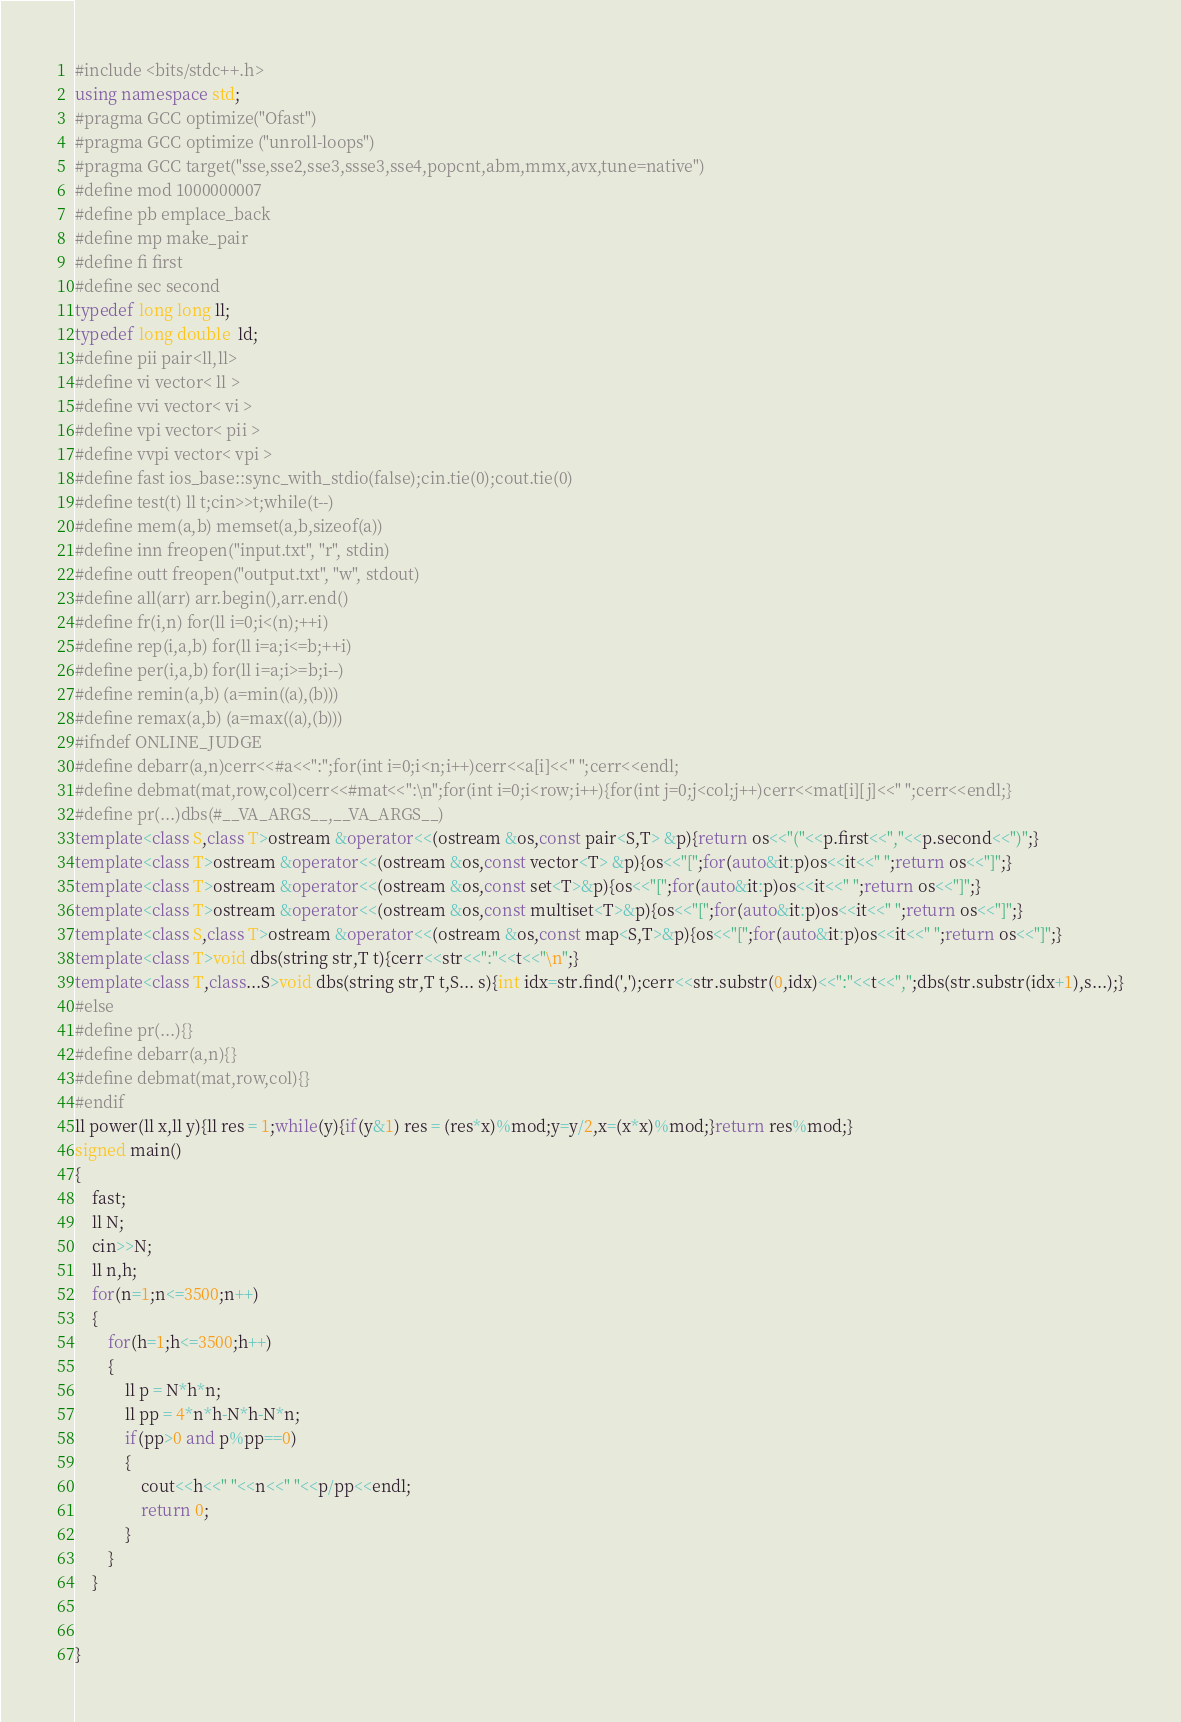Convert code to text. <code><loc_0><loc_0><loc_500><loc_500><_C++_>#include <bits/stdc++.h>
using namespace std;
#pragma GCC optimize("Ofast")
#pragma GCC optimize ("unroll-loops")
#pragma GCC target("sse,sse2,sse3,ssse3,sse4,popcnt,abm,mmx,avx,tune=native")
#define mod 1000000007
#define pb emplace_back
#define mp make_pair
#define fi first
#define sec second
typedef long long ll;
typedef long double  ld;
#define pii pair<ll,ll> 
#define vi vector< ll > 
#define vvi vector< vi > 
#define vpi vector< pii > 
#define vvpi vector< vpi > 
#define fast ios_base::sync_with_stdio(false);cin.tie(0);cout.tie(0)
#define test(t) ll t;cin>>t;while(t--)
#define mem(a,b) memset(a,b,sizeof(a))
#define inn freopen("input.txt", "r", stdin)
#define outt freopen("output.txt", "w", stdout)
#define all(arr) arr.begin(),arr.end()
#define fr(i,n) for(ll i=0;i<(n);++i)
#define rep(i,a,b) for(ll i=a;i<=b;++i)
#define per(i,a,b) for(ll i=a;i>=b;i--)
#define remin(a,b) (a=min((a),(b)))
#define remax(a,b) (a=max((a),(b)))
#ifndef ONLINE_JUDGE
#define debarr(a,n)cerr<<#a<<":";for(int i=0;i<n;i++)cerr<<a[i]<<" ";cerr<<endl;
#define debmat(mat,row,col)cerr<<#mat<<":\n";for(int i=0;i<row;i++){for(int j=0;j<col;j++)cerr<<mat[i][j]<<" ";cerr<<endl;}
#define pr(...)dbs(#__VA_ARGS__,__VA_ARGS__)
template<class S,class T>ostream &operator<<(ostream &os,const pair<S,T> &p){return os<<"("<<p.first<<","<<p.second<<")";}
template<class T>ostream &operator<<(ostream &os,const vector<T> &p){os<<"[";for(auto&it:p)os<<it<<" ";return os<<"]";}
template<class T>ostream &operator<<(ostream &os,const set<T>&p){os<<"[";for(auto&it:p)os<<it<<" ";return os<<"]";}
template<class T>ostream &operator<<(ostream &os,const multiset<T>&p){os<<"[";for(auto&it:p)os<<it<<" ";return os<<"]";}
template<class S,class T>ostream &operator<<(ostream &os,const map<S,T>&p){os<<"[";for(auto&it:p)os<<it<<" ";return os<<"]";}
template<class T>void dbs(string str,T t){cerr<<str<<":"<<t<<"\n";}
template<class T,class...S>void dbs(string str,T t,S... s){int idx=str.find(',');cerr<<str.substr(0,idx)<<":"<<t<<",";dbs(str.substr(idx+1),s...);}
#else
#define pr(...){}
#define debarr(a,n){}
#define debmat(mat,row,col){}
#endif
ll power(ll x,ll y){ll res = 1;while(y){if(y&1) res = (res*x)%mod;y=y/2,x=(x*x)%mod;}return res%mod;}
signed main()
{
    fast;
    ll N;
    cin>>N;
    ll n,h;
    for(n=1;n<=3500;n++)
    {
    	for(h=1;h<=3500;h++)
    	{
    		ll p = N*h*n;
    		ll pp = 4*n*h-N*h-N*n;
    		if(pp>0 and p%pp==0)
    		{
    			cout<<h<<" "<<n<<" "<<p/pp<<endl;
    			return 0;
    		}
    	}
    }

    
}
</code> 